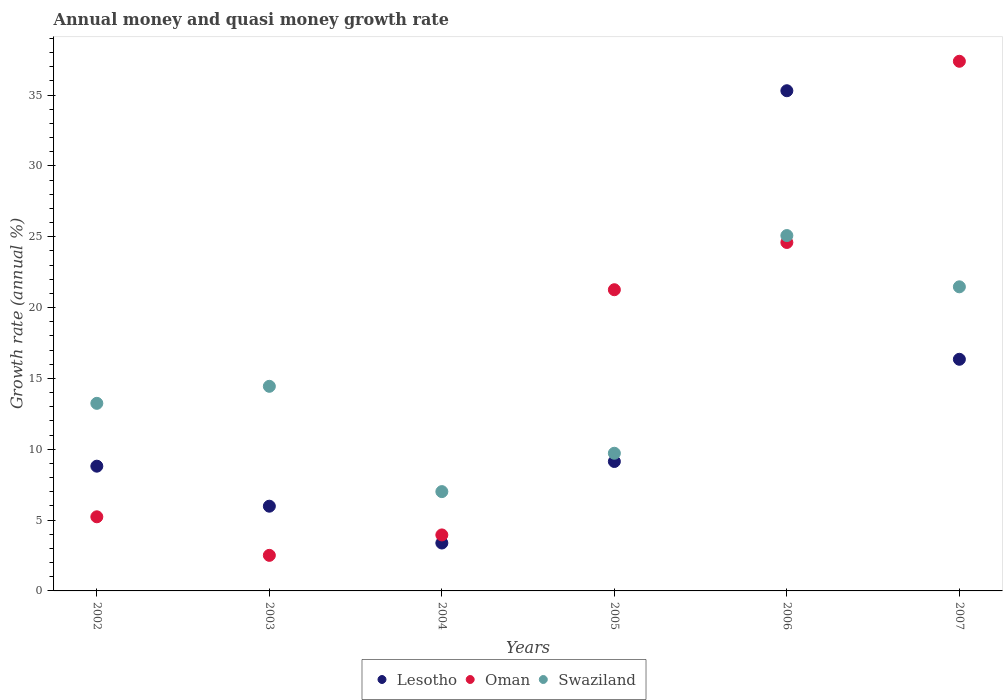How many different coloured dotlines are there?
Make the answer very short. 3. Is the number of dotlines equal to the number of legend labels?
Provide a short and direct response. Yes. What is the growth rate in Oman in 2005?
Offer a terse response. 21.26. Across all years, what is the maximum growth rate in Lesotho?
Ensure brevity in your answer.  35.31. Across all years, what is the minimum growth rate in Swaziland?
Ensure brevity in your answer.  7.01. In which year was the growth rate in Lesotho maximum?
Offer a terse response. 2006. In which year was the growth rate in Oman minimum?
Provide a short and direct response. 2003. What is the total growth rate in Oman in the graph?
Ensure brevity in your answer.  94.94. What is the difference between the growth rate in Oman in 2002 and that in 2005?
Your answer should be compact. -16.03. What is the difference between the growth rate in Oman in 2006 and the growth rate in Lesotho in 2003?
Offer a very short reply. 18.62. What is the average growth rate in Oman per year?
Your answer should be compact. 15.82. In the year 2004, what is the difference between the growth rate in Lesotho and growth rate in Oman?
Your response must be concise. -0.57. In how many years, is the growth rate in Lesotho greater than 37 %?
Your response must be concise. 0. What is the ratio of the growth rate in Swaziland in 2003 to that in 2005?
Make the answer very short. 1.49. What is the difference between the highest and the second highest growth rate in Lesotho?
Provide a short and direct response. 18.96. What is the difference between the highest and the lowest growth rate in Lesotho?
Ensure brevity in your answer.  31.92. In how many years, is the growth rate in Oman greater than the average growth rate in Oman taken over all years?
Your response must be concise. 3. How many years are there in the graph?
Ensure brevity in your answer.  6. What is the difference between two consecutive major ticks on the Y-axis?
Make the answer very short. 5. Does the graph contain grids?
Keep it short and to the point. No. Where does the legend appear in the graph?
Keep it short and to the point. Bottom center. How are the legend labels stacked?
Keep it short and to the point. Horizontal. What is the title of the graph?
Your answer should be very brief. Annual money and quasi money growth rate. What is the label or title of the Y-axis?
Your answer should be very brief. Growth rate (annual %). What is the Growth rate (annual %) of Lesotho in 2002?
Your response must be concise. 8.81. What is the Growth rate (annual %) of Oman in 2002?
Make the answer very short. 5.23. What is the Growth rate (annual %) of Swaziland in 2002?
Your answer should be compact. 13.24. What is the Growth rate (annual %) in Lesotho in 2003?
Provide a succinct answer. 5.98. What is the Growth rate (annual %) in Oman in 2003?
Your response must be concise. 2.51. What is the Growth rate (annual %) in Swaziland in 2003?
Your answer should be very brief. 14.44. What is the Growth rate (annual %) of Lesotho in 2004?
Offer a very short reply. 3.38. What is the Growth rate (annual %) in Oman in 2004?
Make the answer very short. 3.95. What is the Growth rate (annual %) of Swaziland in 2004?
Ensure brevity in your answer.  7.01. What is the Growth rate (annual %) in Lesotho in 2005?
Keep it short and to the point. 9.14. What is the Growth rate (annual %) in Oman in 2005?
Keep it short and to the point. 21.26. What is the Growth rate (annual %) of Swaziland in 2005?
Offer a terse response. 9.72. What is the Growth rate (annual %) of Lesotho in 2006?
Keep it short and to the point. 35.31. What is the Growth rate (annual %) of Oman in 2006?
Offer a terse response. 24.6. What is the Growth rate (annual %) of Swaziland in 2006?
Provide a succinct answer. 25.08. What is the Growth rate (annual %) in Lesotho in 2007?
Your answer should be compact. 16.35. What is the Growth rate (annual %) in Oman in 2007?
Offer a very short reply. 37.39. What is the Growth rate (annual %) in Swaziland in 2007?
Your answer should be compact. 21.47. Across all years, what is the maximum Growth rate (annual %) in Lesotho?
Ensure brevity in your answer.  35.31. Across all years, what is the maximum Growth rate (annual %) of Oman?
Your answer should be very brief. 37.39. Across all years, what is the maximum Growth rate (annual %) in Swaziland?
Your answer should be compact. 25.08. Across all years, what is the minimum Growth rate (annual %) of Lesotho?
Your answer should be compact. 3.38. Across all years, what is the minimum Growth rate (annual %) of Oman?
Give a very brief answer. 2.51. Across all years, what is the minimum Growth rate (annual %) in Swaziland?
Your response must be concise. 7.01. What is the total Growth rate (annual %) of Lesotho in the graph?
Your response must be concise. 78.96. What is the total Growth rate (annual %) in Oman in the graph?
Your answer should be very brief. 94.94. What is the total Growth rate (annual %) of Swaziland in the graph?
Provide a short and direct response. 90.96. What is the difference between the Growth rate (annual %) of Lesotho in 2002 and that in 2003?
Make the answer very short. 2.82. What is the difference between the Growth rate (annual %) in Oman in 2002 and that in 2003?
Ensure brevity in your answer.  2.72. What is the difference between the Growth rate (annual %) of Swaziland in 2002 and that in 2003?
Ensure brevity in your answer.  -1.2. What is the difference between the Growth rate (annual %) of Lesotho in 2002 and that in 2004?
Your answer should be compact. 5.42. What is the difference between the Growth rate (annual %) in Oman in 2002 and that in 2004?
Ensure brevity in your answer.  1.28. What is the difference between the Growth rate (annual %) in Swaziland in 2002 and that in 2004?
Give a very brief answer. 6.23. What is the difference between the Growth rate (annual %) in Lesotho in 2002 and that in 2005?
Provide a short and direct response. -0.33. What is the difference between the Growth rate (annual %) of Oman in 2002 and that in 2005?
Provide a short and direct response. -16.03. What is the difference between the Growth rate (annual %) of Swaziland in 2002 and that in 2005?
Offer a very short reply. 3.52. What is the difference between the Growth rate (annual %) in Lesotho in 2002 and that in 2006?
Provide a short and direct response. -26.5. What is the difference between the Growth rate (annual %) of Oman in 2002 and that in 2006?
Ensure brevity in your answer.  -19.36. What is the difference between the Growth rate (annual %) of Swaziland in 2002 and that in 2006?
Provide a succinct answer. -11.84. What is the difference between the Growth rate (annual %) of Lesotho in 2002 and that in 2007?
Your response must be concise. -7.54. What is the difference between the Growth rate (annual %) in Oman in 2002 and that in 2007?
Your answer should be very brief. -32.15. What is the difference between the Growth rate (annual %) of Swaziland in 2002 and that in 2007?
Ensure brevity in your answer.  -8.22. What is the difference between the Growth rate (annual %) in Lesotho in 2003 and that in 2004?
Keep it short and to the point. 2.6. What is the difference between the Growth rate (annual %) of Oman in 2003 and that in 2004?
Offer a very short reply. -1.44. What is the difference between the Growth rate (annual %) of Swaziland in 2003 and that in 2004?
Your answer should be compact. 7.43. What is the difference between the Growth rate (annual %) of Lesotho in 2003 and that in 2005?
Ensure brevity in your answer.  -3.15. What is the difference between the Growth rate (annual %) of Oman in 2003 and that in 2005?
Keep it short and to the point. -18.75. What is the difference between the Growth rate (annual %) of Swaziland in 2003 and that in 2005?
Ensure brevity in your answer.  4.72. What is the difference between the Growth rate (annual %) in Lesotho in 2003 and that in 2006?
Keep it short and to the point. -29.33. What is the difference between the Growth rate (annual %) in Oman in 2003 and that in 2006?
Give a very brief answer. -22.08. What is the difference between the Growth rate (annual %) in Swaziland in 2003 and that in 2006?
Your answer should be compact. -10.64. What is the difference between the Growth rate (annual %) in Lesotho in 2003 and that in 2007?
Provide a short and direct response. -10.37. What is the difference between the Growth rate (annual %) of Oman in 2003 and that in 2007?
Offer a very short reply. -34.87. What is the difference between the Growth rate (annual %) in Swaziland in 2003 and that in 2007?
Offer a very short reply. -7.02. What is the difference between the Growth rate (annual %) in Lesotho in 2004 and that in 2005?
Give a very brief answer. -5.75. What is the difference between the Growth rate (annual %) of Oman in 2004 and that in 2005?
Your answer should be compact. -17.31. What is the difference between the Growth rate (annual %) of Swaziland in 2004 and that in 2005?
Your answer should be very brief. -2.71. What is the difference between the Growth rate (annual %) of Lesotho in 2004 and that in 2006?
Keep it short and to the point. -31.92. What is the difference between the Growth rate (annual %) in Oman in 2004 and that in 2006?
Ensure brevity in your answer.  -20.64. What is the difference between the Growth rate (annual %) in Swaziland in 2004 and that in 2006?
Ensure brevity in your answer.  -18.07. What is the difference between the Growth rate (annual %) of Lesotho in 2004 and that in 2007?
Keep it short and to the point. -12.97. What is the difference between the Growth rate (annual %) in Oman in 2004 and that in 2007?
Make the answer very short. -33.43. What is the difference between the Growth rate (annual %) of Swaziland in 2004 and that in 2007?
Give a very brief answer. -14.46. What is the difference between the Growth rate (annual %) of Lesotho in 2005 and that in 2006?
Give a very brief answer. -26.17. What is the difference between the Growth rate (annual %) of Oman in 2005 and that in 2006?
Your answer should be very brief. -3.34. What is the difference between the Growth rate (annual %) in Swaziland in 2005 and that in 2006?
Your response must be concise. -15.37. What is the difference between the Growth rate (annual %) in Lesotho in 2005 and that in 2007?
Offer a terse response. -7.21. What is the difference between the Growth rate (annual %) in Oman in 2005 and that in 2007?
Keep it short and to the point. -16.13. What is the difference between the Growth rate (annual %) in Swaziland in 2005 and that in 2007?
Make the answer very short. -11.75. What is the difference between the Growth rate (annual %) in Lesotho in 2006 and that in 2007?
Ensure brevity in your answer.  18.96. What is the difference between the Growth rate (annual %) of Oman in 2006 and that in 2007?
Provide a succinct answer. -12.79. What is the difference between the Growth rate (annual %) in Swaziland in 2006 and that in 2007?
Provide a succinct answer. 3.62. What is the difference between the Growth rate (annual %) in Lesotho in 2002 and the Growth rate (annual %) in Oman in 2003?
Your response must be concise. 6.29. What is the difference between the Growth rate (annual %) in Lesotho in 2002 and the Growth rate (annual %) in Swaziland in 2003?
Ensure brevity in your answer.  -5.64. What is the difference between the Growth rate (annual %) in Oman in 2002 and the Growth rate (annual %) in Swaziland in 2003?
Make the answer very short. -9.21. What is the difference between the Growth rate (annual %) in Lesotho in 2002 and the Growth rate (annual %) in Oman in 2004?
Offer a terse response. 4.85. What is the difference between the Growth rate (annual %) in Lesotho in 2002 and the Growth rate (annual %) in Swaziland in 2004?
Make the answer very short. 1.8. What is the difference between the Growth rate (annual %) in Oman in 2002 and the Growth rate (annual %) in Swaziland in 2004?
Offer a very short reply. -1.78. What is the difference between the Growth rate (annual %) in Lesotho in 2002 and the Growth rate (annual %) in Oman in 2005?
Provide a succinct answer. -12.45. What is the difference between the Growth rate (annual %) in Lesotho in 2002 and the Growth rate (annual %) in Swaziland in 2005?
Provide a short and direct response. -0.91. What is the difference between the Growth rate (annual %) in Oman in 2002 and the Growth rate (annual %) in Swaziland in 2005?
Provide a succinct answer. -4.49. What is the difference between the Growth rate (annual %) in Lesotho in 2002 and the Growth rate (annual %) in Oman in 2006?
Keep it short and to the point. -15.79. What is the difference between the Growth rate (annual %) in Lesotho in 2002 and the Growth rate (annual %) in Swaziland in 2006?
Your answer should be very brief. -16.28. What is the difference between the Growth rate (annual %) in Oman in 2002 and the Growth rate (annual %) in Swaziland in 2006?
Offer a very short reply. -19.85. What is the difference between the Growth rate (annual %) in Lesotho in 2002 and the Growth rate (annual %) in Oman in 2007?
Give a very brief answer. -28.58. What is the difference between the Growth rate (annual %) in Lesotho in 2002 and the Growth rate (annual %) in Swaziland in 2007?
Provide a short and direct response. -12.66. What is the difference between the Growth rate (annual %) of Oman in 2002 and the Growth rate (annual %) of Swaziland in 2007?
Provide a succinct answer. -16.23. What is the difference between the Growth rate (annual %) in Lesotho in 2003 and the Growth rate (annual %) in Oman in 2004?
Provide a succinct answer. 2.03. What is the difference between the Growth rate (annual %) of Lesotho in 2003 and the Growth rate (annual %) of Swaziland in 2004?
Your answer should be compact. -1.03. What is the difference between the Growth rate (annual %) in Oman in 2003 and the Growth rate (annual %) in Swaziland in 2004?
Keep it short and to the point. -4.5. What is the difference between the Growth rate (annual %) of Lesotho in 2003 and the Growth rate (annual %) of Oman in 2005?
Your response must be concise. -15.28. What is the difference between the Growth rate (annual %) of Lesotho in 2003 and the Growth rate (annual %) of Swaziland in 2005?
Your answer should be compact. -3.74. What is the difference between the Growth rate (annual %) in Oman in 2003 and the Growth rate (annual %) in Swaziland in 2005?
Provide a short and direct response. -7.21. What is the difference between the Growth rate (annual %) in Lesotho in 2003 and the Growth rate (annual %) in Oman in 2006?
Your answer should be compact. -18.62. What is the difference between the Growth rate (annual %) in Lesotho in 2003 and the Growth rate (annual %) in Swaziland in 2006?
Your answer should be very brief. -19.1. What is the difference between the Growth rate (annual %) in Oman in 2003 and the Growth rate (annual %) in Swaziland in 2006?
Ensure brevity in your answer.  -22.57. What is the difference between the Growth rate (annual %) of Lesotho in 2003 and the Growth rate (annual %) of Oman in 2007?
Provide a short and direct response. -31.4. What is the difference between the Growth rate (annual %) in Lesotho in 2003 and the Growth rate (annual %) in Swaziland in 2007?
Your response must be concise. -15.48. What is the difference between the Growth rate (annual %) of Oman in 2003 and the Growth rate (annual %) of Swaziland in 2007?
Offer a very short reply. -18.95. What is the difference between the Growth rate (annual %) of Lesotho in 2004 and the Growth rate (annual %) of Oman in 2005?
Give a very brief answer. -17.88. What is the difference between the Growth rate (annual %) in Lesotho in 2004 and the Growth rate (annual %) in Swaziland in 2005?
Provide a short and direct response. -6.34. What is the difference between the Growth rate (annual %) in Oman in 2004 and the Growth rate (annual %) in Swaziland in 2005?
Ensure brevity in your answer.  -5.77. What is the difference between the Growth rate (annual %) of Lesotho in 2004 and the Growth rate (annual %) of Oman in 2006?
Ensure brevity in your answer.  -21.21. What is the difference between the Growth rate (annual %) of Lesotho in 2004 and the Growth rate (annual %) of Swaziland in 2006?
Your answer should be compact. -21.7. What is the difference between the Growth rate (annual %) of Oman in 2004 and the Growth rate (annual %) of Swaziland in 2006?
Offer a terse response. -21.13. What is the difference between the Growth rate (annual %) of Lesotho in 2004 and the Growth rate (annual %) of Oman in 2007?
Provide a short and direct response. -34. What is the difference between the Growth rate (annual %) in Lesotho in 2004 and the Growth rate (annual %) in Swaziland in 2007?
Give a very brief answer. -18.08. What is the difference between the Growth rate (annual %) of Oman in 2004 and the Growth rate (annual %) of Swaziland in 2007?
Your response must be concise. -17.51. What is the difference between the Growth rate (annual %) of Lesotho in 2005 and the Growth rate (annual %) of Oman in 2006?
Keep it short and to the point. -15.46. What is the difference between the Growth rate (annual %) in Lesotho in 2005 and the Growth rate (annual %) in Swaziland in 2006?
Your response must be concise. -15.95. What is the difference between the Growth rate (annual %) of Oman in 2005 and the Growth rate (annual %) of Swaziland in 2006?
Keep it short and to the point. -3.82. What is the difference between the Growth rate (annual %) in Lesotho in 2005 and the Growth rate (annual %) in Oman in 2007?
Your answer should be compact. -28.25. What is the difference between the Growth rate (annual %) in Lesotho in 2005 and the Growth rate (annual %) in Swaziland in 2007?
Keep it short and to the point. -12.33. What is the difference between the Growth rate (annual %) of Oman in 2005 and the Growth rate (annual %) of Swaziland in 2007?
Make the answer very short. -0.21. What is the difference between the Growth rate (annual %) in Lesotho in 2006 and the Growth rate (annual %) in Oman in 2007?
Your answer should be compact. -2.08. What is the difference between the Growth rate (annual %) in Lesotho in 2006 and the Growth rate (annual %) in Swaziland in 2007?
Keep it short and to the point. 13.84. What is the difference between the Growth rate (annual %) of Oman in 2006 and the Growth rate (annual %) of Swaziland in 2007?
Your response must be concise. 3.13. What is the average Growth rate (annual %) in Lesotho per year?
Keep it short and to the point. 13.16. What is the average Growth rate (annual %) of Oman per year?
Offer a terse response. 15.82. What is the average Growth rate (annual %) of Swaziland per year?
Provide a short and direct response. 15.16. In the year 2002, what is the difference between the Growth rate (annual %) of Lesotho and Growth rate (annual %) of Oman?
Ensure brevity in your answer.  3.57. In the year 2002, what is the difference between the Growth rate (annual %) in Lesotho and Growth rate (annual %) in Swaziland?
Your answer should be compact. -4.44. In the year 2002, what is the difference between the Growth rate (annual %) in Oman and Growth rate (annual %) in Swaziland?
Provide a succinct answer. -8.01. In the year 2003, what is the difference between the Growth rate (annual %) of Lesotho and Growth rate (annual %) of Oman?
Provide a short and direct response. 3.47. In the year 2003, what is the difference between the Growth rate (annual %) in Lesotho and Growth rate (annual %) in Swaziland?
Ensure brevity in your answer.  -8.46. In the year 2003, what is the difference between the Growth rate (annual %) of Oman and Growth rate (annual %) of Swaziland?
Offer a very short reply. -11.93. In the year 2004, what is the difference between the Growth rate (annual %) of Lesotho and Growth rate (annual %) of Oman?
Keep it short and to the point. -0.57. In the year 2004, what is the difference between the Growth rate (annual %) of Lesotho and Growth rate (annual %) of Swaziland?
Your answer should be very brief. -3.63. In the year 2004, what is the difference between the Growth rate (annual %) of Oman and Growth rate (annual %) of Swaziland?
Provide a succinct answer. -3.06. In the year 2005, what is the difference between the Growth rate (annual %) in Lesotho and Growth rate (annual %) in Oman?
Your response must be concise. -12.12. In the year 2005, what is the difference between the Growth rate (annual %) in Lesotho and Growth rate (annual %) in Swaziland?
Ensure brevity in your answer.  -0.58. In the year 2005, what is the difference between the Growth rate (annual %) of Oman and Growth rate (annual %) of Swaziland?
Give a very brief answer. 11.54. In the year 2006, what is the difference between the Growth rate (annual %) in Lesotho and Growth rate (annual %) in Oman?
Keep it short and to the point. 10.71. In the year 2006, what is the difference between the Growth rate (annual %) in Lesotho and Growth rate (annual %) in Swaziland?
Your response must be concise. 10.22. In the year 2006, what is the difference between the Growth rate (annual %) in Oman and Growth rate (annual %) in Swaziland?
Offer a terse response. -0.49. In the year 2007, what is the difference between the Growth rate (annual %) in Lesotho and Growth rate (annual %) in Oman?
Your response must be concise. -21.03. In the year 2007, what is the difference between the Growth rate (annual %) of Lesotho and Growth rate (annual %) of Swaziland?
Your response must be concise. -5.12. In the year 2007, what is the difference between the Growth rate (annual %) in Oman and Growth rate (annual %) in Swaziland?
Ensure brevity in your answer.  15.92. What is the ratio of the Growth rate (annual %) of Lesotho in 2002 to that in 2003?
Make the answer very short. 1.47. What is the ratio of the Growth rate (annual %) of Oman in 2002 to that in 2003?
Keep it short and to the point. 2.08. What is the ratio of the Growth rate (annual %) of Swaziland in 2002 to that in 2003?
Your answer should be very brief. 0.92. What is the ratio of the Growth rate (annual %) in Lesotho in 2002 to that in 2004?
Give a very brief answer. 2.6. What is the ratio of the Growth rate (annual %) in Oman in 2002 to that in 2004?
Keep it short and to the point. 1.32. What is the ratio of the Growth rate (annual %) in Swaziland in 2002 to that in 2004?
Provide a succinct answer. 1.89. What is the ratio of the Growth rate (annual %) in Lesotho in 2002 to that in 2005?
Provide a short and direct response. 0.96. What is the ratio of the Growth rate (annual %) of Oman in 2002 to that in 2005?
Make the answer very short. 0.25. What is the ratio of the Growth rate (annual %) of Swaziland in 2002 to that in 2005?
Offer a terse response. 1.36. What is the ratio of the Growth rate (annual %) in Lesotho in 2002 to that in 2006?
Make the answer very short. 0.25. What is the ratio of the Growth rate (annual %) of Oman in 2002 to that in 2006?
Keep it short and to the point. 0.21. What is the ratio of the Growth rate (annual %) in Swaziland in 2002 to that in 2006?
Offer a very short reply. 0.53. What is the ratio of the Growth rate (annual %) in Lesotho in 2002 to that in 2007?
Give a very brief answer. 0.54. What is the ratio of the Growth rate (annual %) of Oman in 2002 to that in 2007?
Provide a short and direct response. 0.14. What is the ratio of the Growth rate (annual %) in Swaziland in 2002 to that in 2007?
Provide a short and direct response. 0.62. What is the ratio of the Growth rate (annual %) in Lesotho in 2003 to that in 2004?
Your answer should be compact. 1.77. What is the ratio of the Growth rate (annual %) in Oman in 2003 to that in 2004?
Make the answer very short. 0.64. What is the ratio of the Growth rate (annual %) in Swaziland in 2003 to that in 2004?
Ensure brevity in your answer.  2.06. What is the ratio of the Growth rate (annual %) of Lesotho in 2003 to that in 2005?
Ensure brevity in your answer.  0.65. What is the ratio of the Growth rate (annual %) of Oman in 2003 to that in 2005?
Your answer should be very brief. 0.12. What is the ratio of the Growth rate (annual %) of Swaziland in 2003 to that in 2005?
Your answer should be compact. 1.49. What is the ratio of the Growth rate (annual %) of Lesotho in 2003 to that in 2006?
Offer a very short reply. 0.17. What is the ratio of the Growth rate (annual %) of Oman in 2003 to that in 2006?
Your answer should be compact. 0.1. What is the ratio of the Growth rate (annual %) of Swaziland in 2003 to that in 2006?
Offer a terse response. 0.58. What is the ratio of the Growth rate (annual %) in Lesotho in 2003 to that in 2007?
Your answer should be very brief. 0.37. What is the ratio of the Growth rate (annual %) of Oman in 2003 to that in 2007?
Your answer should be compact. 0.07. What is the ratio of the Growth rate (annual %) in Swaziland in 2003 to that in 2007?
Offer a terse response. 0.67. What is the ratio of the Growth rate (annual %) of Lesotho in 2004 to that in 2005?
Give a very brief answer. 0.37. What is the ratio of the Growth rate (annual %) of Oman in 2004 to that in 2005?
Your response must be concise. 0.19. What is the ratio of the Growth rate (annual %) in Swaziland in 2004 to that in 2005?
Keep it short and to the point. 0.72. What is the ratio of the Growth rate (annual %) of Lesotho in 2004 to that in 2006?
Provide a short and direct response. 0.1. What is the ratio of the Growth rate (annual %) of Oman in 2004 to that in 2006?
Your answer should be compact. 0.16. What is the ratio of the Growth rate (annual %) of Swaziland in 2004 to that in 2006?
Offer a very short reply. 0.28. What is the ratio of the Growth rate (annual %) in Lesotho in 2004 to that in 2007?
Offer a very short reply. 0.21. What is the ratio of the Growth rate (annual %) in Oman in 2004 to that in 2007?
Provide a succinct answer. 0.11. What is the ratio of the Growth rate (annual %) of Swaziland in 2004 to that in 2007?
Give a very brief answer. 0.33. What is the ratio of the Growth rate (annual %) of Lesotho in 2005 to that in 2006?
Give a very brief answer. 0.26. What is the ratio of the Growth rate (annual %) of Oman in 2005 to that in 2006?
Provide a short and direct response. 0.86. What is the ratio of the Growth rate (annual %) in Swaziland in 2005 to that in 2006?
Keep it short and to the point. 0.39. What is the ratio of the Growth rate (annual %) of Lesotho in 2005 to that in 2007?
Your response must be concise. 0.56. What is the ratio of the Growth rate (annual %) in Oman in 2005 to that in 2007?
Your answer should be very brief. 0.57. What is the ratio of the Growth rate (annual %) of Swaziland in 2005 to that in 2007?
Provide a succinct answer. 0.45. What is the ratio of the Growth rate (annual %) of Lesotho in 2006 to that in 2007?
Offer a very short reply. 2.16. What is the ratio of the Growth rate (annual %) in Oman in 2006 to that in 2007?
Ensure brevity in your answer.  0.66. What is the ratio of the Growth rate (annual %) in Swaziland in 2006 to that in 2007?
Keep it short and to the point. 1.17. What is the difference between the highest and the second highest Growth rate (annual %) of Lesotho?
Provide a succinct answer. 18.96. What is the difference between the highest and the second highest Growth rate (annual %) in Oman?
Provide a short and direct response. 12.79. What is the difference between the highest and the second highest Growth rate (annual %) in Swaziland?
Your response must be concise. 3.62. What is the difference between the highest and the lowest Growth rate (annual %) in Lesotho?
Your response must be concise. 31.92. What is the difference between the highest and the lowest Growth rate (annual %) of Oman?
Offer a very short reply. 34.87. What is the difference between the highest and the lowest Growth rate (annual %) of Swaziland?
Your response must be concise. 18.07. 